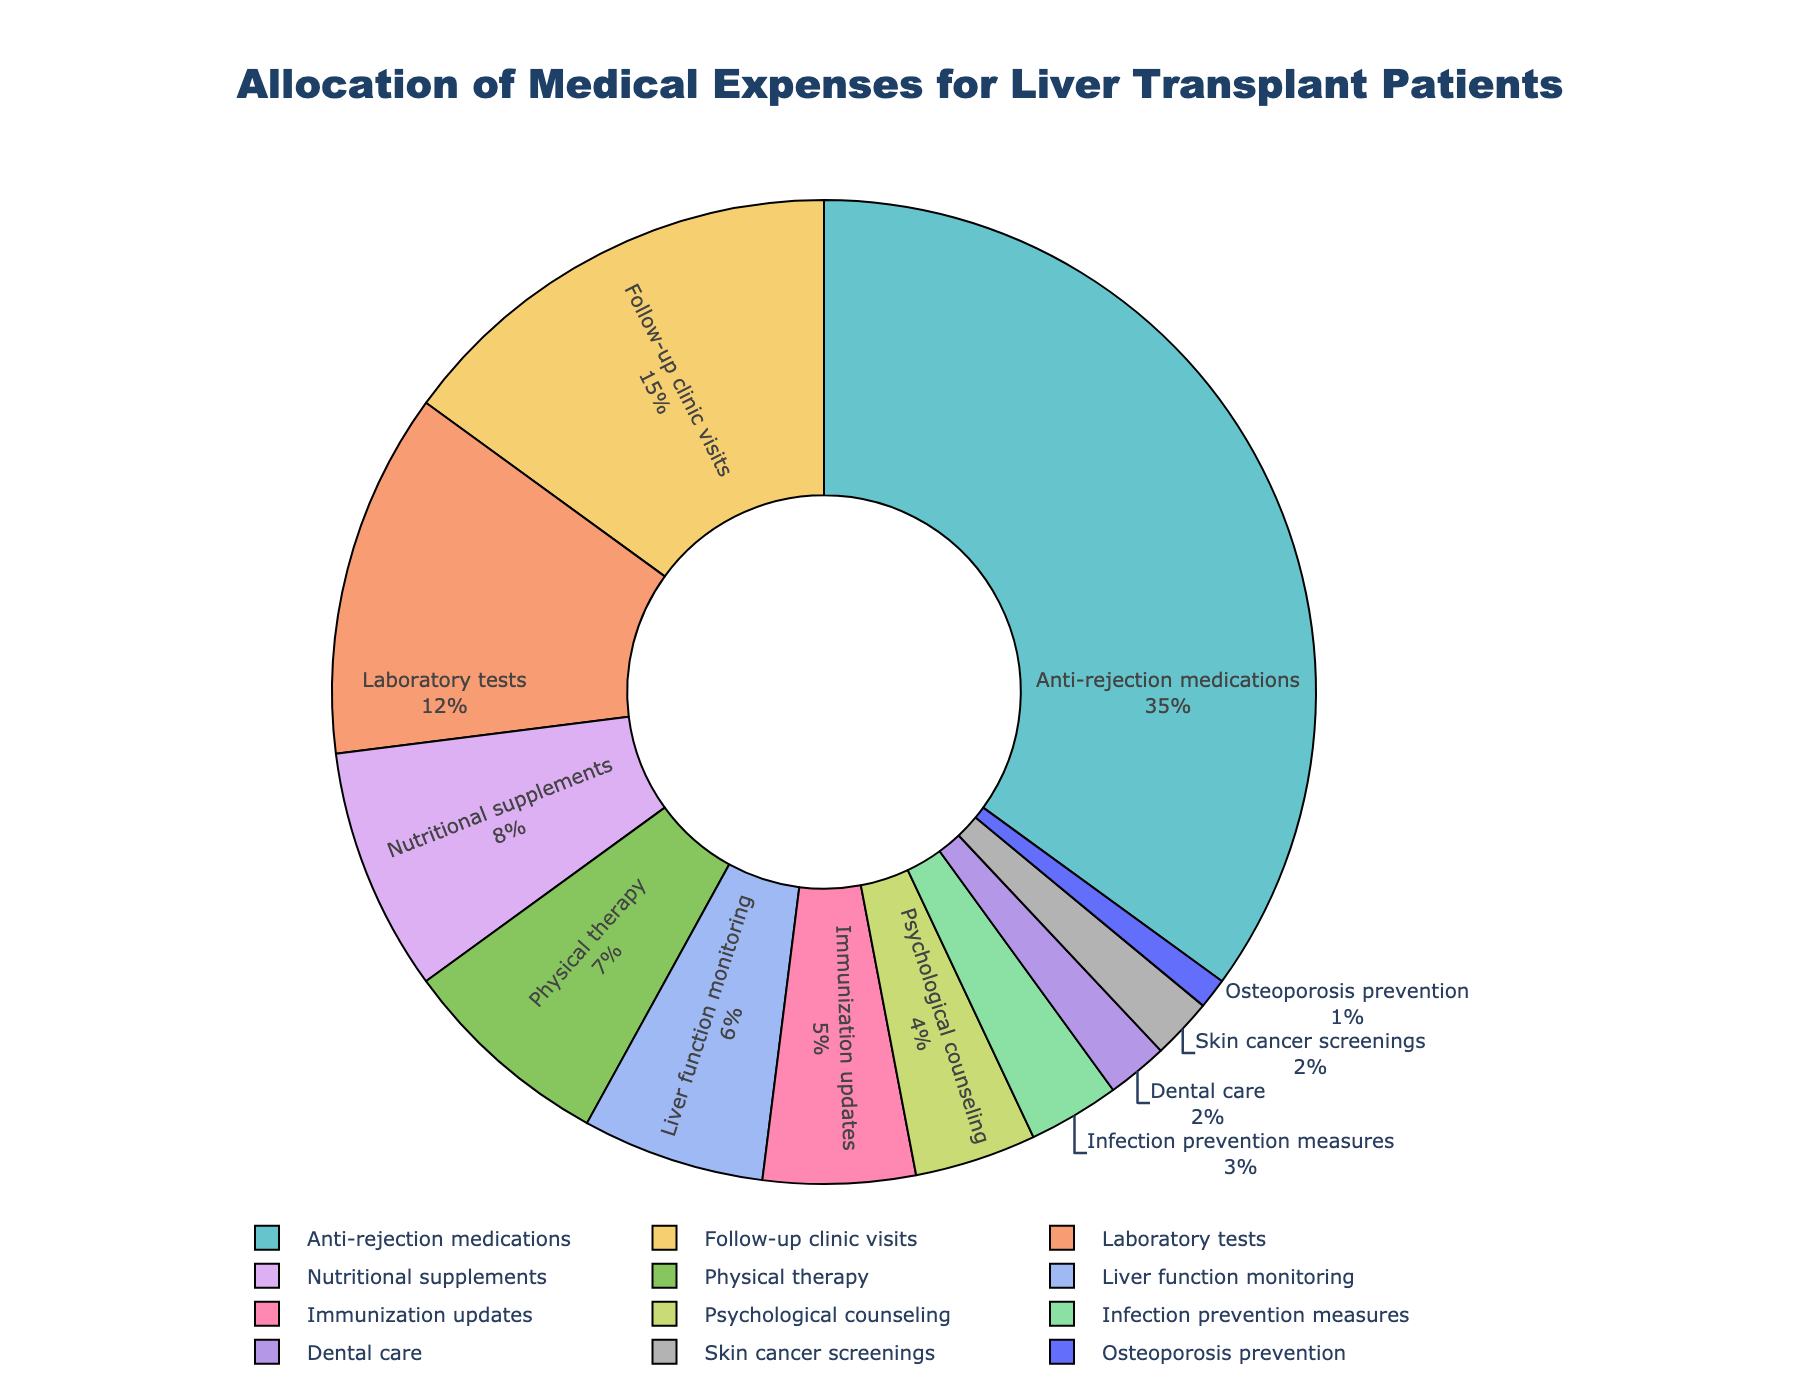What is the category with the highest percentage allocation of medical expenses? By inspecting the pie chart, we can identify that "Anti-rejection medications" has the largest section.
Answer: Anti-rejection medications What is the combined percentage of expenses for laboratory tests, nutritional supplements, and physical therapy? Add the percentages of each category: Laboratory tests (12%), Nutritional supplements (8%), and Physical therapy (7%). The combined total is 12 + 8 + 7 = 27%.
Answer: 27% Which categories have an equal percentage allocation of medical expenses? Looking closely, we can see that "Dental care" and "Skin cancer screenings" both hold the same percentage of 2%.
Answer: Dental care and Skin cancer screenings What is the difference in percentage allocation between follow-up clinic visits and psychological counseling? Subtract the percentage of psychological counseling (4%) from the percentage of follow-up clinic visits (15%). The difference is 15 - 4 = 11%.
Answer: 11% How does the percentage allocation of infection prevention measures compare to immunization updates? Compare the two percentages: Infection prevention measures (3%) and Immunization updates (5%). Immunization updates have a higher percentage.
Answer: Immunization updates have a higher percentage What percentage of the total allocation is spent on dental care and osteoporosis prevention together? Add the percentages of dental care (2%) and osteoporosis prevention (1%). The combined percentage is 2 + 1 = 3%.
Answer: 3% Which category is assigned the smallest percentage of medical expenses? Identify the smallest section in the pie chart, which corresponds to "Osteoporosis prevention" with 1%.
Answer: Osteoporosis prevention What is the average percentage allocation for the categories with a percentage greater than 10%? Identify the relevant categories, which are "Anti-rejection medications" (35%) and "Follow-up clinic visits" (15%). Calculate the average by summing these percentages and dividing by the number of categories: (35 + 15) / 2 = 25%.
Answer: 25% What is the ratio of the percentage allocation for anti-rejection medications to physical therapy? Compute the ratio by dividing the percentage of anti-rejection medications (35%) by physical therapy (7%). The ratio is 35 / 7 = 5.
Answer: 5 Are there more categories with a percentage allocation below or above 5%? Count the categories below 5% (Dental care, Skin cancer screenings, Osteoporosis prevention, Psychological counseling, Infection prevention measures) and above 5% (Anti-rejection medications, Follow-up clinic visits, Laboratory tests, Nutritional supplements, Physical therapy, Immunization updates, Liver function monitoring). There are 5 categories below and 7 above.
Answer: More above 5% 